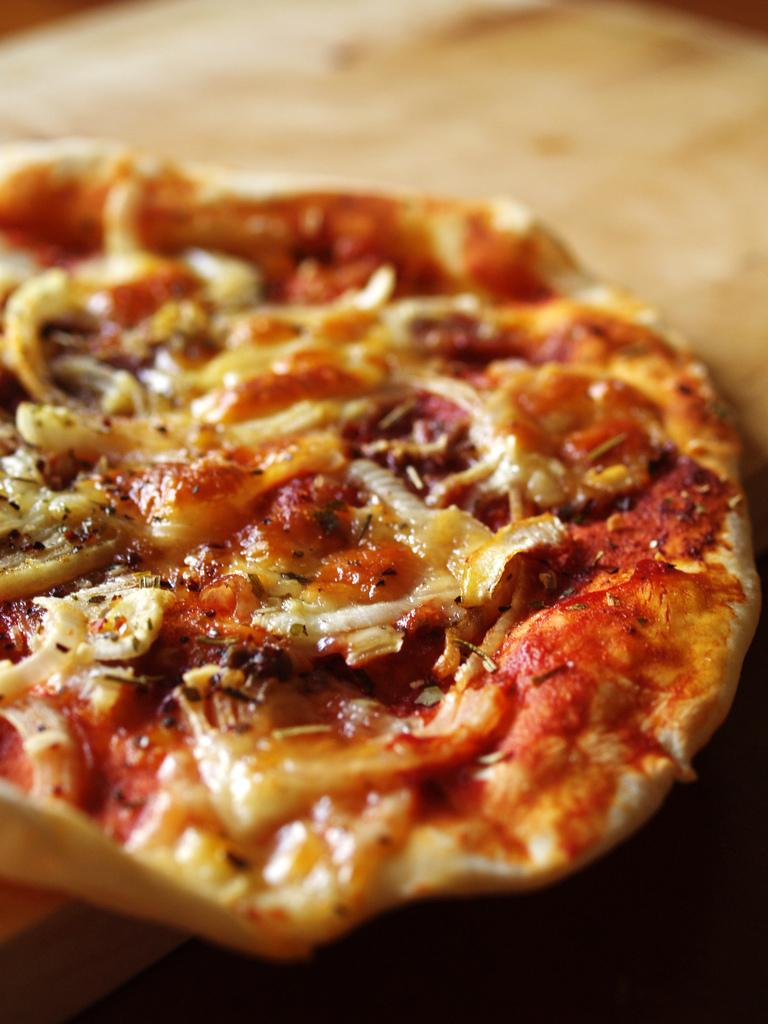What is the main subject of the image? There is a food item on the surface in the image. Can you tell me the position of the goat in the image? There is no goat present in the image. 